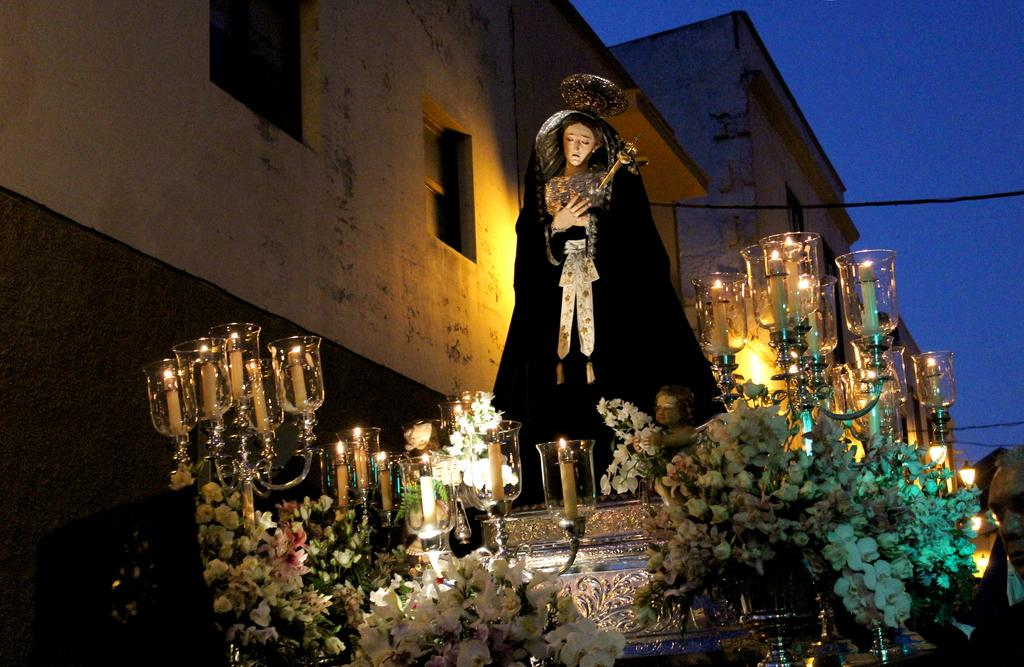What is the main subject in the image? There is a statue in the image. What items are placed near the statue? There are candles with stands near the statue. What type of decorations are present in the image? There are flower bouquets in the image. What can be seen on the sides of the image? There are buildings on the sides of the image. What is visible in the background of the image? The sky is visible in the background of the image. What was the purpose of the war that took place in the image? There is no war depicted in the image; it features a statue, candles, flower bouquets, buildings, and the sky. 